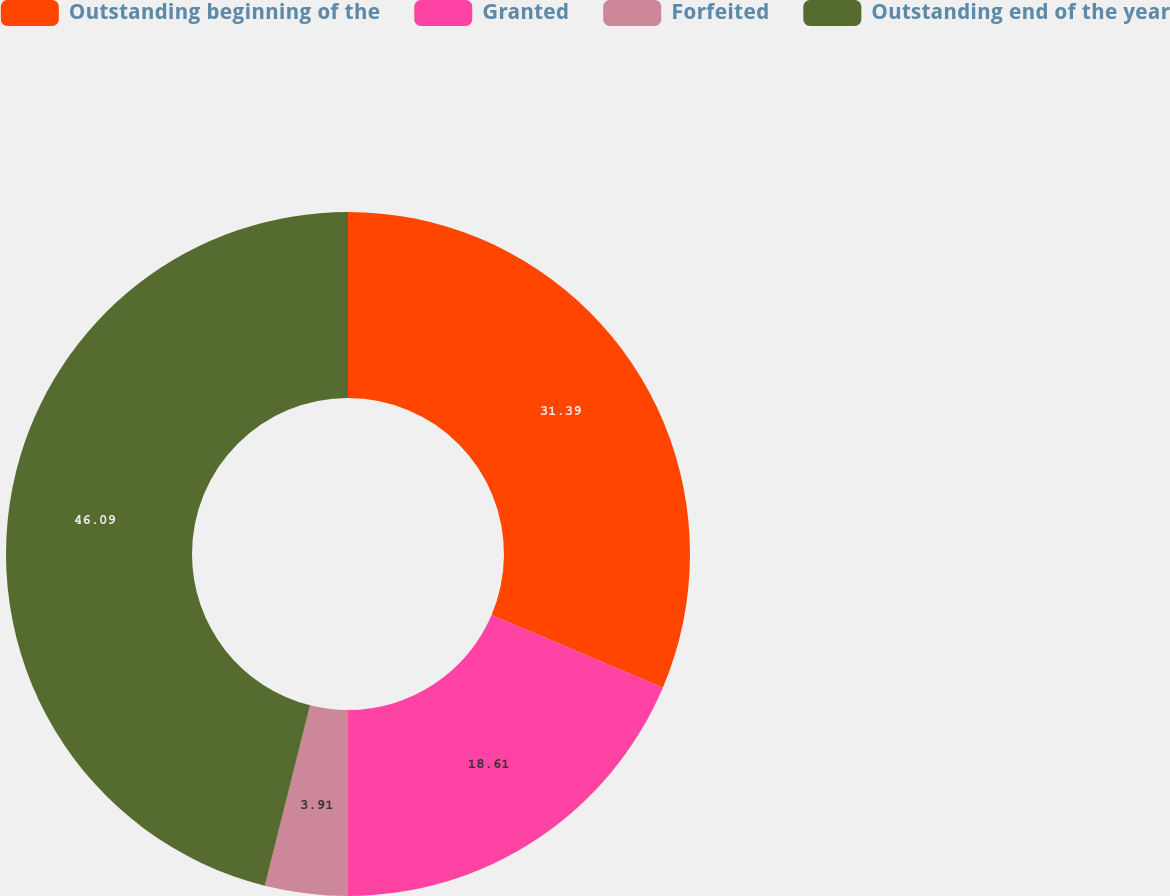<chart> <loc_0><loc_0><loc_500><loc_500><pie_chart><fcel>Outstanding beginning of the<fcel>Granted<fcel>Forfeited<fcel>Outstanding end of the year<nl><fcel>31.39%<fcel>18.61%<fcel>3.91%<fcel>46.09%<nl></chart> 